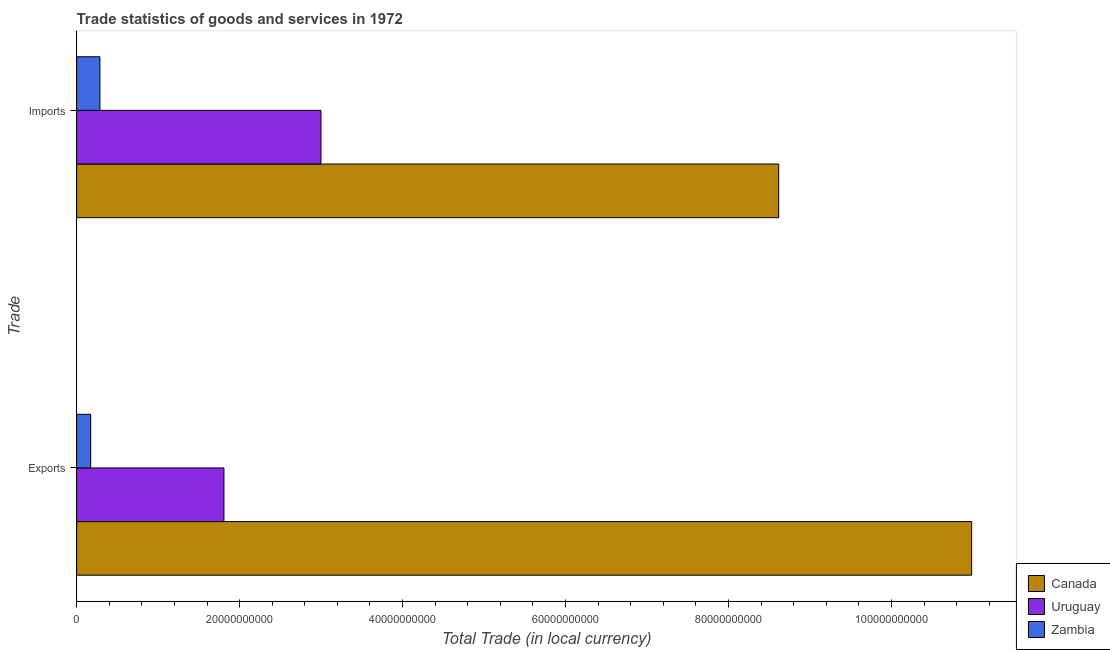How many different coloured bars are there?
Provide a short and direct response. 3. What is the label of the 2nd group of bars from the top?
Ensure brevity in your answer.  Exports. What is the imports of goods and services in Uruguay?
Your answer should be compact. 3.00e+1. Across all countries, what is the maximum export of goods and services?
Keep it short and to the point. 1.10e+11. Across all countries, what is the minimum export of goods and services?
Offer a terse response. 1.72e+09. In which country was the imports of goods and services maximum?
Ensure brevity in your answer.  Canada. In which country was the imports of goods and services minimum?
Give a very brief answer. Zambia. What is the total imports of goods and services in the graph?
Keep it short and to the point. 1.19e+11. What is the difference between the imports of goods and services in Uruguay and that in Zambia?
Provide a succinct answer. 2.71e+1. What is the difference between the imports of goods and services in Zambia and the export of goods and services in Uruguay?
Your response must be concise. -1.52e+1. What is the average imports of goods and services per country?
Your response must be concise. 3.97e+1. What is the difference between the export of goods and services and imports of goods and services in Canada?
Give a very brief answer. 2.37e+1. In how many countries, is the export of goods and services greater than 64000000000 LCU?
Your response must be concise. 1. What is the ratio of the export of goods and services in Uruguay to that in Canada?
Keep it short and to the point. 0.16. What does the 2nd bar from the top in Exports represents?
Make the answer very short. Uruguay. How many countries are there in the graph?
Give a very brief answer. 3. What is the difference between two consecutive major ticks on the X-axis?
Your response must be concise. 2.00e+1. Does the graph contain any zero values?
Provide a short and direct response. No. Does the graph contain grids?
Offer a terse response. No. What is the title of the graph?
Keep it short and to the point. Trade statistics of goods and services in 1972. Does "St. Lucia" appear as one of the legend labels in the graph?
Give a very brief answer. No. What is the label or title of the X-axis?
Ensure brevity in your answer.  Total Trade (in local currency). What is the label or title of the Y-axis?
Your response must be concise. Trade. What is the Total Trade (in local currency) in Canada in Exports?
Offer a very short reply. 1.10e+11. What is the Total Trade (in local currency) of Uruguay in Exports?
Make the answer very short. 1.81e+1. What is the Total Trade (in local currency) in Zambia in Exports?
Provide a succinct answer. 1.72e+09. What is the Total Trade (in local currency) in Canada in Imports?
Ensure brevity in your answer.  8.62e+1. What is the Total Trade (in local currency) of Uruguay in Imports?
Provide a short and direct response. 3.00e+1. What is the Total Trade (in local currency) in Zambia in Imports?
Your response must be concise. 2.86e+09. Across all Trade, what is the maximum Total Trade (in local currency) of Canada?
Give a very brief answer. 1.10e+11. Across all Trade, what is the maximum Total Trade (in local currency) of Uruguay?
Offer a terse response. 3.00e+1. Across all Trade, what is the maximum Total Trade (in local currency) in Zambia?
Make the answer very short. 2.86e+09. Across all Trade, what is the minimum Total Trade (in local currency) in Canada?
Your answer should be very brief. 8.62e+1. Across all Trade, what is the minimum Total Trade (in local currency) of Uruguay?
Make the answer very short. 1.81e+1. Across all Trade, what is the minimum Total Trade (in local currency) in Zambia?
Provide a short and direct response. 1.72e+09. What is the total Total Trade (in local currency) of Canada in the graph?
Make the answer very short. 1.96e+11. What is the total Total Trade (in local currency) in Uruguay in the graph?
Your answer should be very brief. 4.81e+1. What is the total Total Trade (in local currency) of Zambia in the graph?
Provide a succinct answer. 4.58e+09. What is the difference between the Total Trade (in local currency) in Canada in Exports and that in Imports?
Give a very brief answer. 2.37e+1. What is the difference between the Total Trade (in local currency) of Uruguay in Exports and that in Imports?
Ensure brevity in your answer.  -1.19e+1. What is the difference between the Total Trade (in local currency) of Zambia in Exports and that in Imports?
Provide a succinct answer. -1.13e+09. What is the difference between the Total Trade (in local currency) of Canada in Exports and the Total Trade (in local currency) of Uruguay in Imports?
Keep it short and to the point. 7.99e+1. What is the difference between the Total Trade (in local currency) in Canada in Exports and the Total Trade (in local currency) in Zambia in Imports?
Ensure brevity in your answer.  1.07e+11. What is the difference between the Total Trade (in local currency) of Uruguay in Exports and the Total Trade (in local currency) of Zambia in Imports?
Your answer should be compact. 1.52e+1. What is the average Total Trade (in local currency) in Canada per Trade?
Offer a terse response. 9.80e+1. What is the average Total Trade (in local currency) in Uruguay per Trade?
Your response must be concise. 2.40e+1. What is the average Total Trade (in local currency) of Zambia per Trade?
Make the answer very short. 2.29e+09. What is the difference between the Total Trade (in local currency) of Canada and Total Trade (in local currency) of Uruguay in Exports?
Make the answer very short. 9.18e+1. What is the difference between the Total Trade (in local currency) in Canada and Total Trade (in local currency) in Zambia in Exports?
Keep it short and to the point. 1.08e+11. What is the difference between the Total Trade (in local currency) of Uruguay and Total Trade (in local currency) of Zambia in Exports?
Make the answer very short. 1.64e+1. What is the difference between the Total Trade (in local currency) in Canada and Total Trade (in local currency) in Uruguay in Imports?
Make the answer very short. 5.62e+1. What is the difference between the Total Trade (in local currency) in Canada and Total Trade (in local currency) in Zambia in Imports?
Ensure brevity in your answer.  8.33e+1. What is the difference between the Total Trade (in local currency) of Uruguay and Total Trade (in local currency) of Zambia in Imports?
Offer a very short reply. 2.71e+1. What is the ratio of the Total Trade (in local currency) of Canada in Exports to that in Imports?
Offer a terse response. 1.27. What is the ratio of the Total Trade (in local currency) of Uruguay in Exports to that in Imports?
Make the answer very short. 0.6. What is the ratio of the Total Trade (in local currency) of Zambia in Exports to that in Imports?
Your answer should be very brief. 0.6. What is the difference between the highest and the second highest Total Trade (in local currency) of Canada?
Offer a very short reply. 2.37e+1. What is the difference between the highest and the second highest Total Trade (in local currency) of Uruguay?
Offer a very short reply. 1.19e+1. What is the difference between the highest and the second highest Total Trade (in local currency) of Zambia?
Your answer should be compact. 1.13e+09. What is the difference between the highest and the lowest Total Trade (in local currency) of Canada?
Your response must be concise. 2.37e+1. What is the difference between the highest and the lowest Total Trade (in local currency) of Uruguay?
Provide a succinct answer. 1.19e+1. What is the difference between the highest and the lowest Total Trade (in local currency) of Zambia?
Your response must be concise. 1.13e+09. 